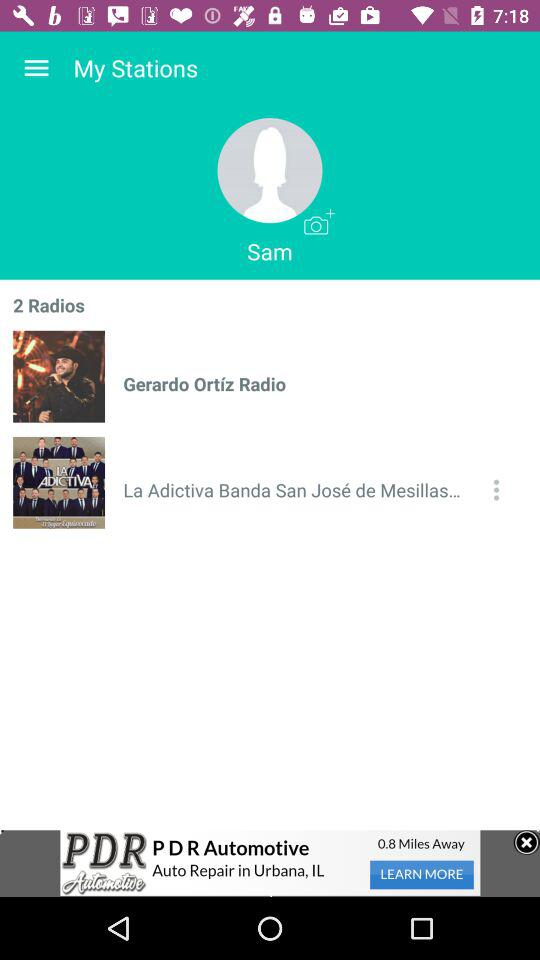What is the name of the user? The name of the user is Sam. 